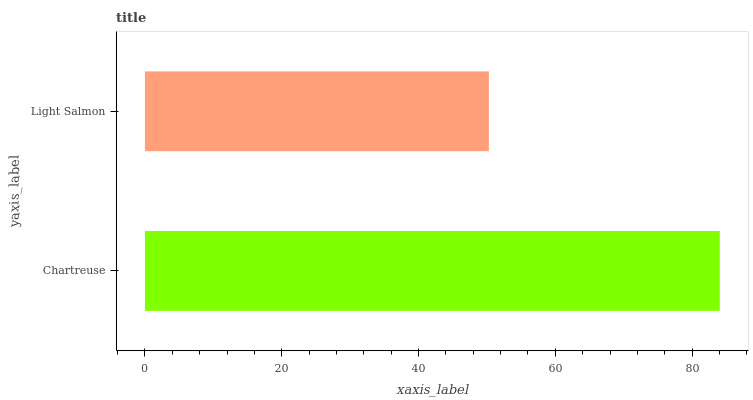Is Light Salmon the minimum?
Answer yes or no. Yes. Is Chartreuse the maximum?
Answer yes or no. Yes. Is Light Salmon the maximum?
Answer yes or no. No. Is Chartreuse greater than Light Salmon?
Answer yes or no. Yes. Is Light Salmon less than Chartreuse?
Answer yes or no. Yes. Is Light Salmon greater than Chartreuse?
Answer yes or no. No. Is Chartreuse less than Light Salmon?
Answer yes or no. No. Is Chartreuse the high median?
Answer yes or no. Yes. Is Light Salmon the low median?
Answer yes or no. Yes. Is Light Salmon the high median?
Answer yes or no. No. Is Chartreuse the low median?
Answer yes or no. No. 